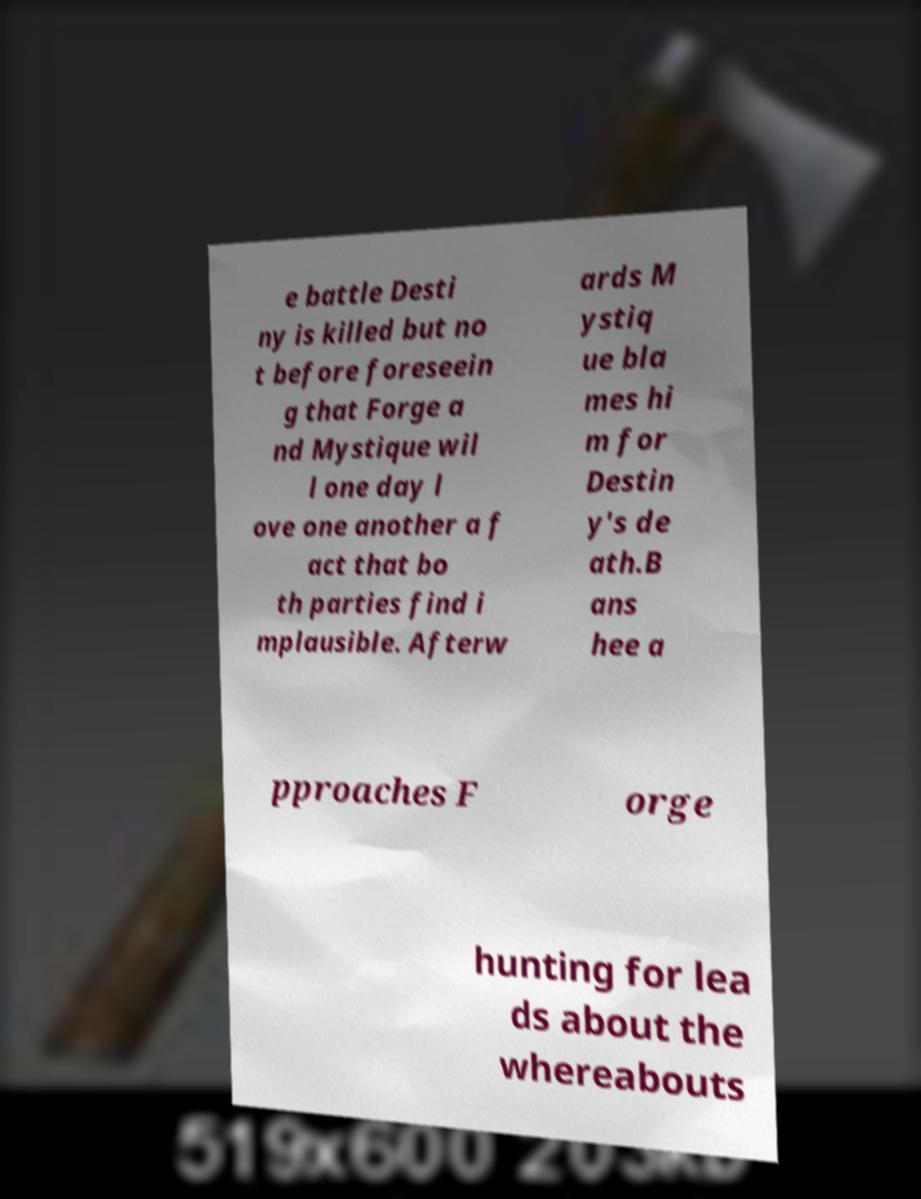Please identify and transcribe the text found in this image. e battle Desti ny is killed but no t before foreseein g that Forge a nd Mystique wil l one day l ove one another a f act that bo th parties find i mplausible. Afterw ards M ystiq ue bla mes hi m for Destin y's de ath.B ans hee a pproaches F orge hunting for lea ds about the whereabouts 